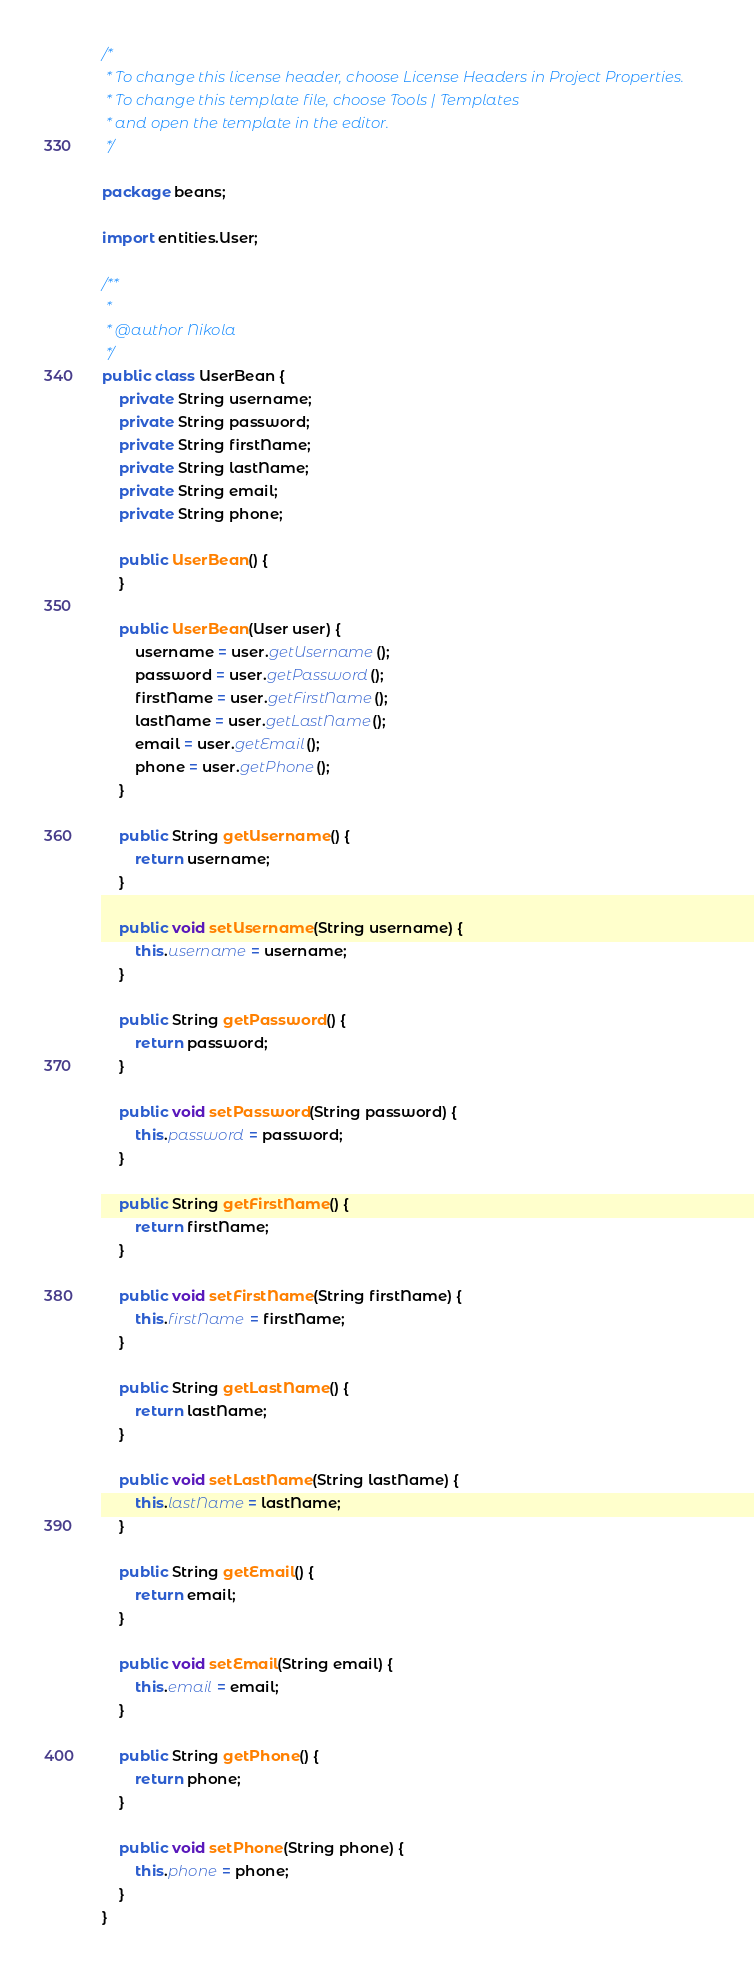<code> <loc_0><loc_0><loc_500><loc_500><_Java_>/*
 * To change this license header, choose License Headers in Project Properties.
 * To change this template file, choose Tools | Templates
 * and open the template in the editor.
 */

package beans;

import entities.User;

/**
 *
 * @author Nikola
 */
public class UserBean {
    private String username;
    private String password;
    private String firstName;
    private String lastName;
    private String email;
    private String phone;

    public UserBean() {
    }
    
    public UserBean(User user) {
        username = user.getUsername();
        password = user.getPassword();
        firstName = user.getFirstName();
        lastName = user.getLastName();
        email = user.getEmail();
        phone = user.getPhone();
    }
    
    public String getUsername() {
        return username;
    }

    public void setUsername(String username) {
        this.username = username;
    }

    public String getPassword() {
        return password;
    }

    public void setPassword(String password) {
        this.password = password;
    }

    public String getFirstName() {
        return firstName;
    }

    public void setFirstName(String firstName) {
        this.firstName = firstName;
    }

    public String getLastName() {
        return lastName;
    }

    public void setLastName(String lastName) {
        this.lastName = lastName;
    }

    public String getEmail() {
        return email;
    }

    public void setEmail(String email) {
        this.email = email;
    }

    public String getPhone() {
        return phone;
    }

    public void setPhone(String phone) {
        this.phone = phone;
    }
}
</code> 